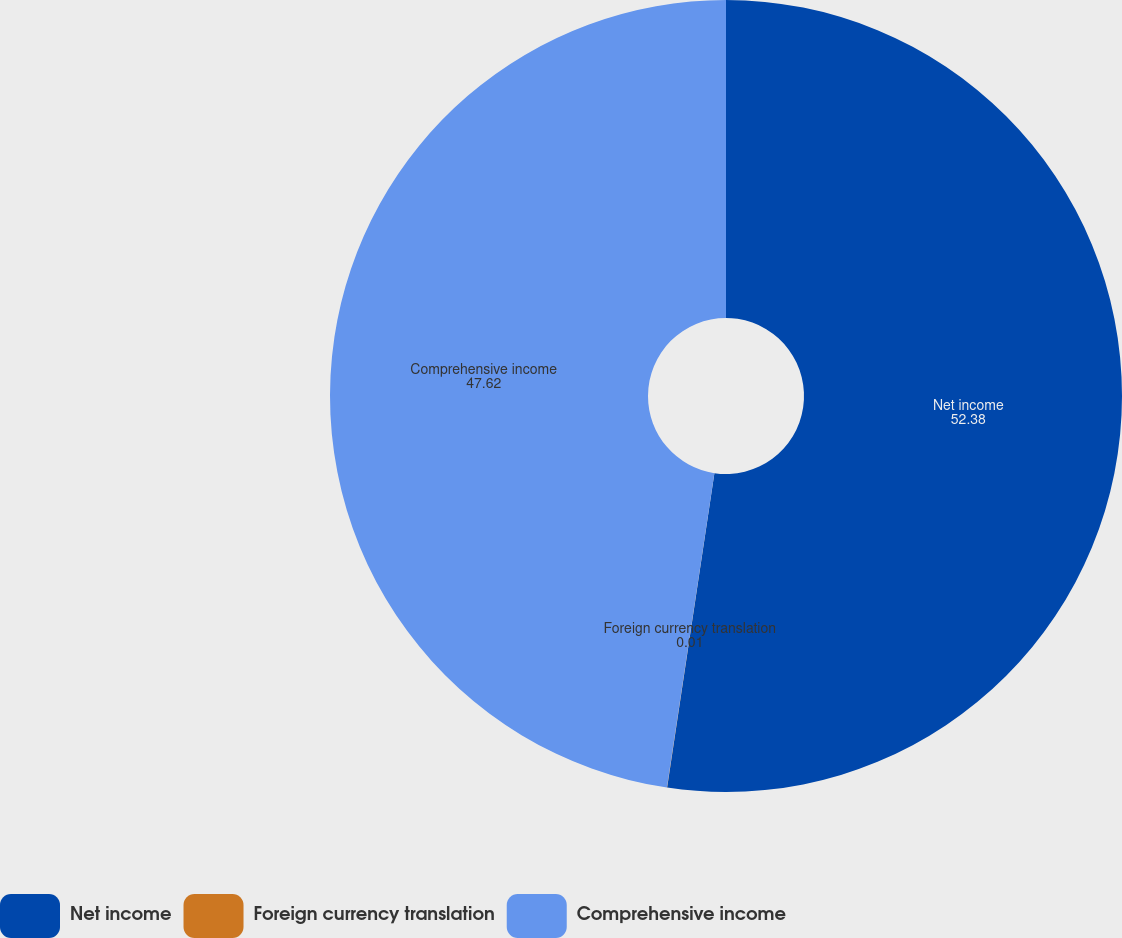<chart> <loc_0><loc_0><loc_500><loc_500><pie_chart><fcel>Net income<fcel>Foreign currency translation<fcel>Comprehensive income<nl><fcel>52.38%<fcel>0.01%<fcel>47.62%<nl></chart> 